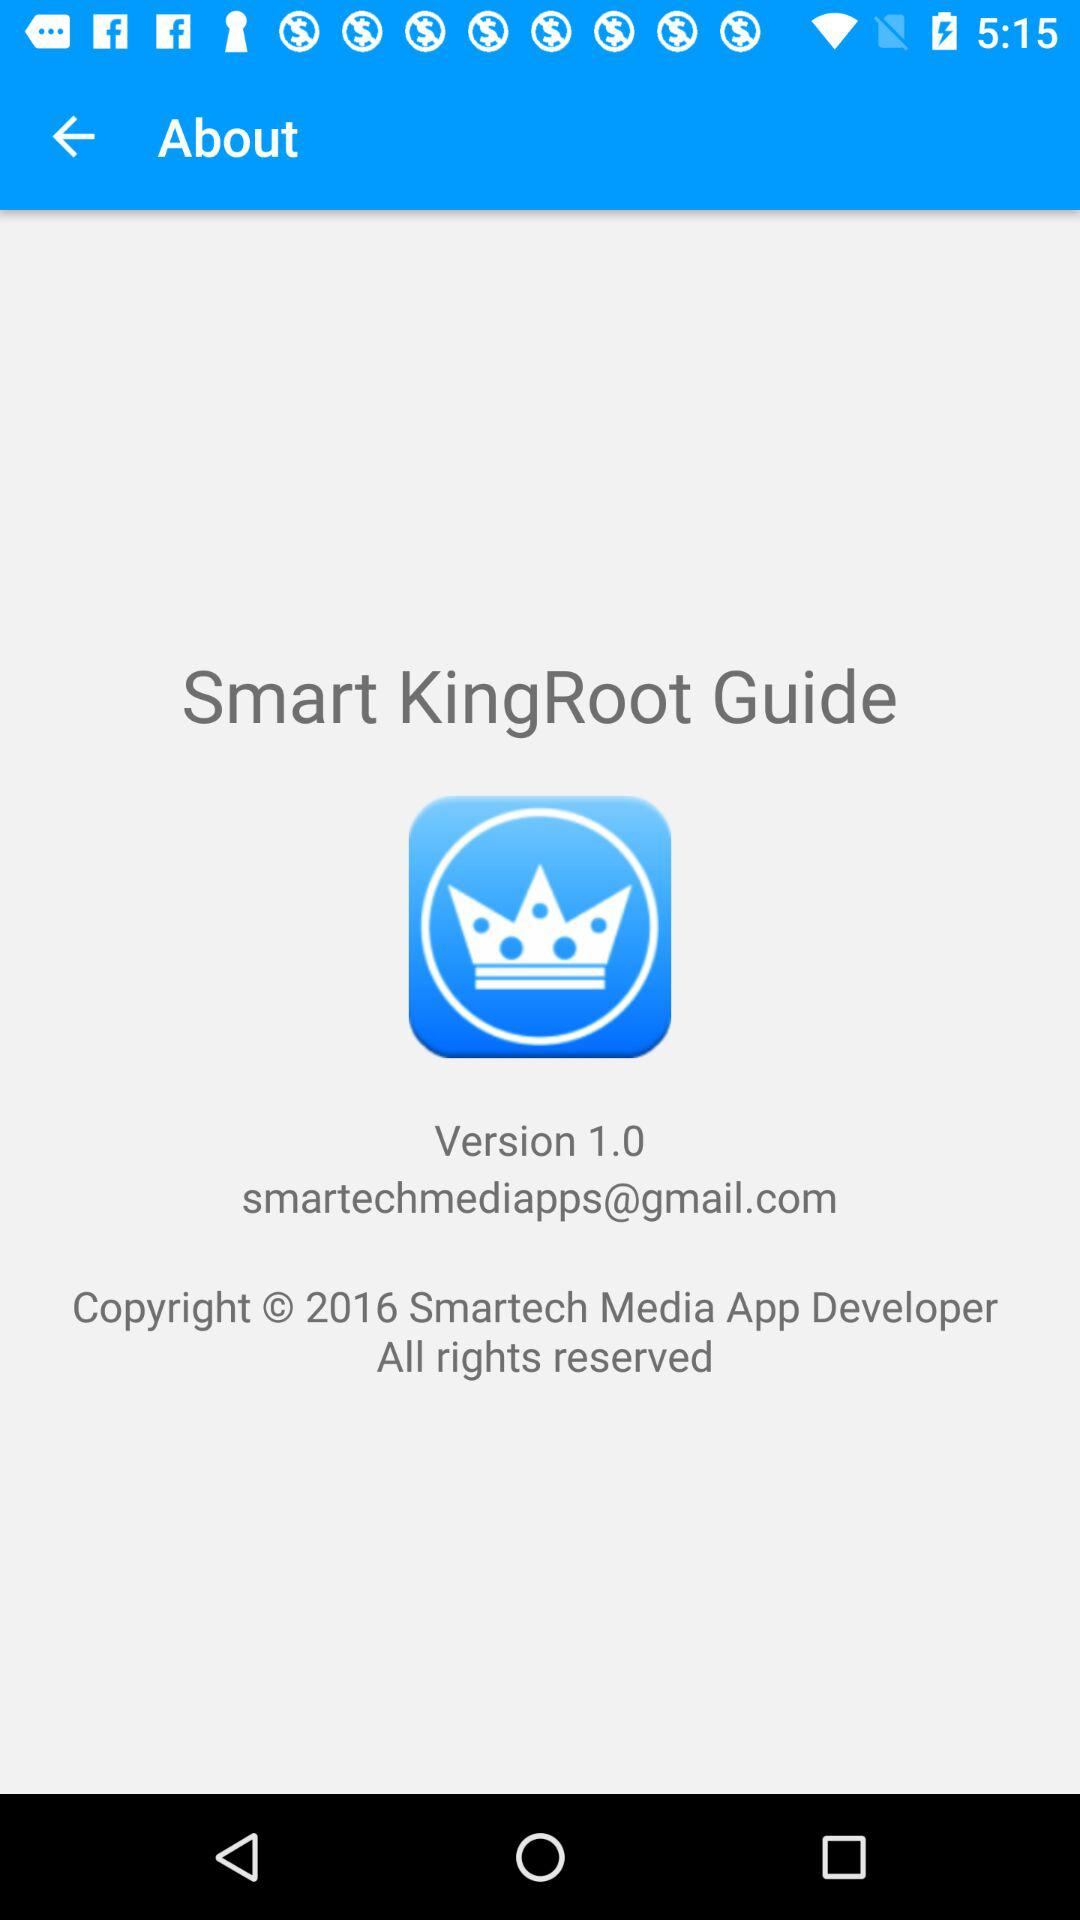What is the email address of the application to contact if there is any issue? The email address is smartechmediapps@gmail.com. 